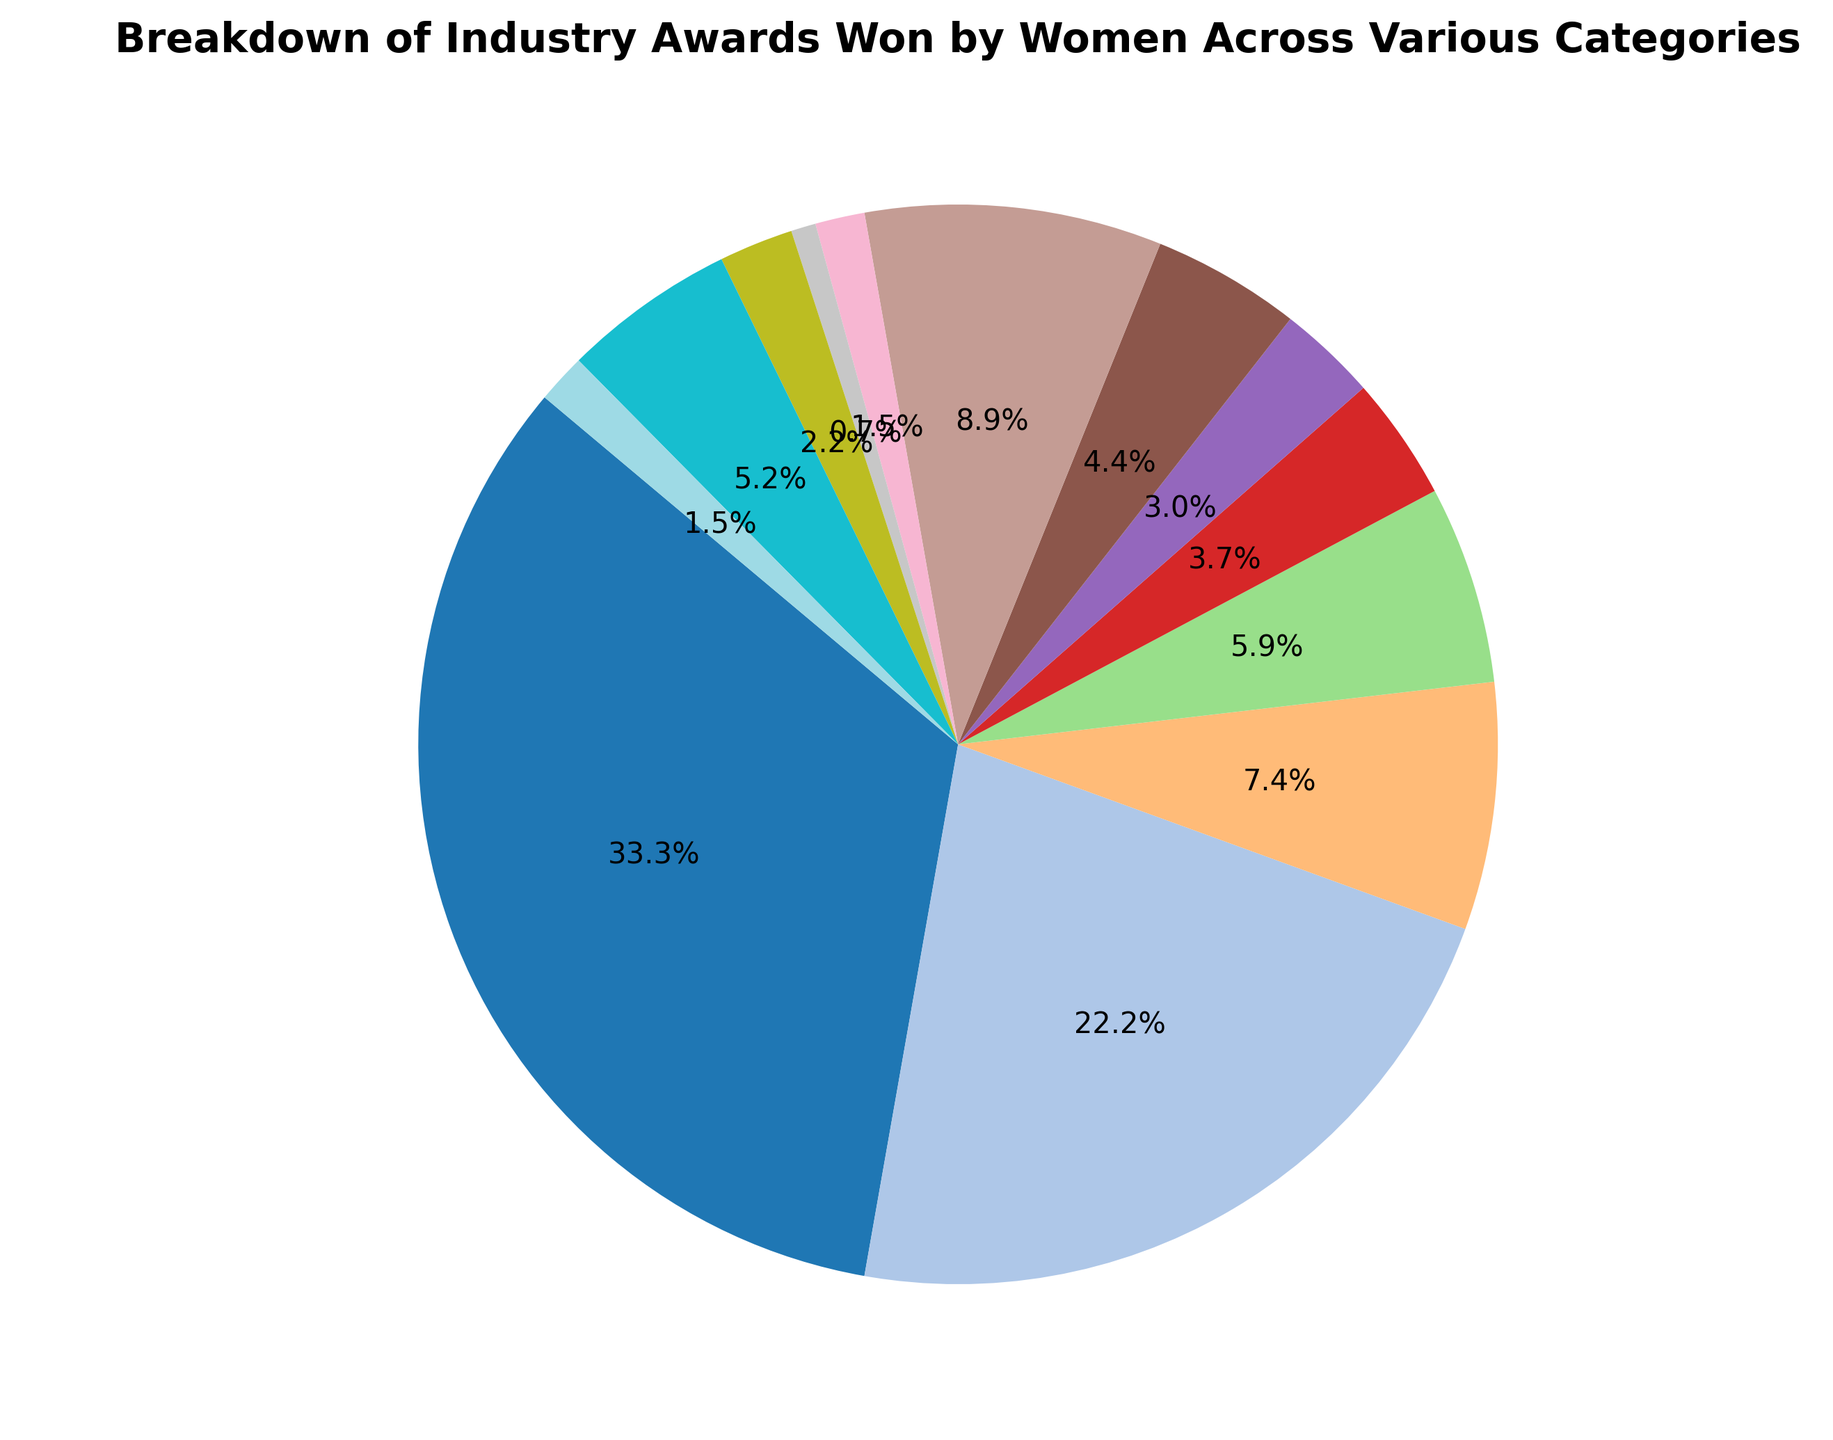Which category has the highest percentage of awards won? The category with the largest slice in the pie chart is identified as having the highest percentage. By looking at the pie chart, the "Best Actress" category has the largest portion.
Answer: Best Actress Which category has the lowest percentage of awards won? The category with the smallest slice in the pie chart is identified as having the lowest percentage. By looking at the pie chart, the "Best Sound Mixing" category has the smallest portion.
Answer: Best Sound Mixing What is the combined percentage of awards for Best Actress and Best Supporting Actress? The percentages for each category can be added directly. The "Best Actress" category has 45% and the "Best Supporting Actress" category has 30%. So, 45% + 30% = 75%.
Answer: 75% How many more awards has Best Director won compared to Best Cinematography? Calculate the difference by subtracting the awards won by Best Cinematography from the awards won by Best Director. Best Director has 10 awards and Best Cinematography has 4 awards, so 10 - 4 = 6.
Answer: 6 Which category among technical roles (like Best Editing, Best Cinematography, Best Sound Editing, Best Sound Mixing, Best Visual Effects) has the highest percentage of awards won? Identify the technical roles and compare their slices in the pie chart. "Best Costume Design" is purely technical and has 12%, which is the highest among the technical categories like "Best Editing", "Best Cinematography", etc.
Answer: Best Costume Design What is the total percentage of awards won by non-acting categories? Sum the percentages of all categories except Best Actress and Best Supporting Actress. To do this, subtract the combined percentage of the acting categories from 100%. That is 100% - 75% = 25%.
Answer: 25% How many more awards have been won by Best Costume Design compared to Best Production Design? Calculate the difference by subtracting the awards won by Best Production Design from the awards won by Best Costume Design. Best Costume Design has 12 awards, and Best Production Design has 6 awards, so 12 - 6 = 6.
Answer: 6 Which category has the biggest visual discrepancy in award count when compared to Best Animated Film? By comparing the award count of Best Animated Film (7 awards) with other categories visually, Best Actress (45 awards) has the largest discrepancy.
Answer: Best Actress What percentage of total awards do the categories with fewer than 10 awards account for combined? Identify the categories with fewer than 10 awards and sum their percentages. These categories are: Best Screenplay (8), Best Editing (5), Best Cinematography (4), Best Production Design (6), Best Sound Editing (2), Best Sound Mixing (1), Best Visual Effects (3), Best Animated Film (7), Best Foreign Language Film (2). Adding their percentages gives 28% + 17% + 6% + 11% + 3% + 1.5% + 3.5% + 6.5% + 2.5% = 59.5%.
Answer: 59.5% 